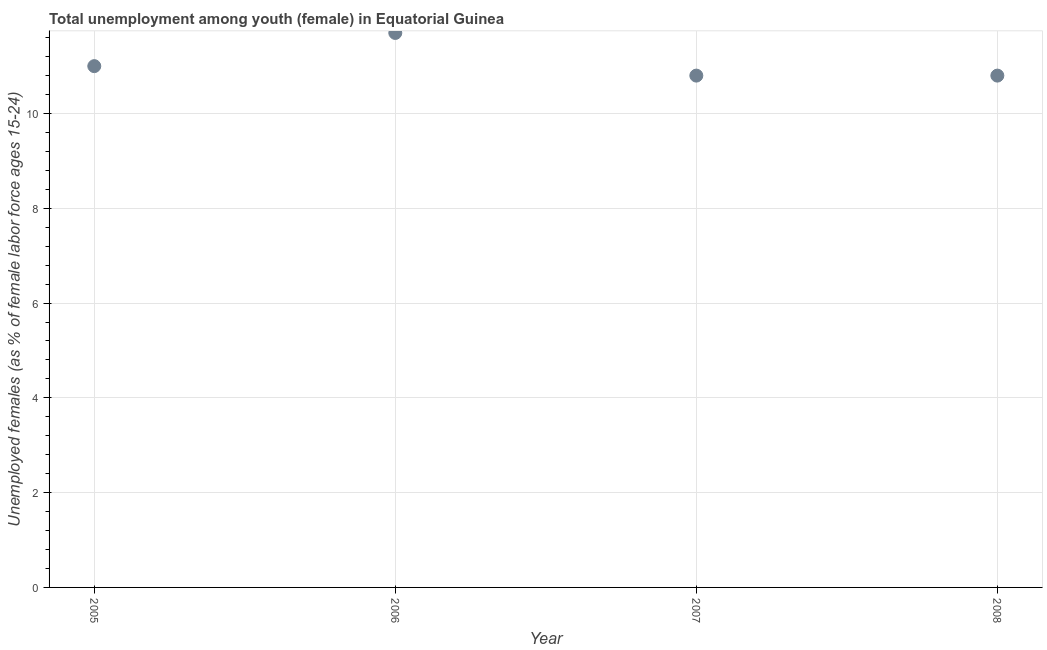What is the unemployed female youth population in 2007?
Keep it short and to the point. 10.8. Across all years, what is the maximum unemployed female youth population?
Your answer should be compact. 11.7. Across all years, what is the minimum unemployed female youth population?
Provide a short and direct response. 10.8. In which year was the unemployed female youth population minimum?
Make the answer very short. 2007. What is the sum of the unemployed female youth population?
Make the answer very short. 44.3. What is the average unemployed female youth population per year?
Provide a succinct answer. 11.08. What is the median unemployed female youth population?
Keep it short and to the point. 10.9. In how many years, is the unemployed female youth population greater than 10.8 %?
Provide a short and direct response. 4. Do a majority of the years between 2006 and 2008 (inclusive) have unemployed female youth population greater than 4.4 %?
Offer a very short reply. Yes. What is the ratio of the unemployed female youth population in 2006 to that in 2008?
Offer a very short reply. 1.08. What is the difference between the highest and the second highest unemployed female youth population?
Keep it short and to the point. 0.7. Is the sum of the unemployed female youth population in 2006 and 2008 greater than the maximum unemployed female youth population across all years?
Your response must be concise. Yes. What is the difference between the highest and the lowest unemployed female youth population?
Offer a very short reply. 0.9. In how many years, is the unemployed female youth population greater than the average unemployed female youth population taken over all years?
Keep it short and to the point. 1. How many dotlines are there?
Ensure brevity in your answer.  1. Does the graph contain any zero values?
Offer a very short reply. No. What is the title of the graph?
Keep it short and to the point. Total unemployment among youth (female) in Equatorial Guinea. What is the label or title of the Y-axis?
Make the answer very short. Unemployed females (as % of female labor force ages 15-24). What is the Unemployed females (as % of female labor force ages 15-24) in 2006?
Offer a very short reply. 11.7. What is the Unemployed females (as % of female labor force ages 15-24) in 2007?
Offer a very short reply. 10.8. What is the Unemployed females (as % of female labor force ages 15-24) in 2008?
Keep it short and to the point. 10.8. What is the difference between the Unemployed females (as % of female labor force ages 15-24) in 2005 and 2006?
Ensure brevity in your answer.  -0.7. What is the difference between the Unemployed females (as % of female labor force ages 15-24) in 2005 and 2007?
Your answer should be compact. 0.2. What is the difference between the Unemployed females (as % of female labor force ages 15-24) in 2005 and 2008?
Make the answer very short. 0.2. What is the difference between the Unemployed females (as % of female labor force ages 15-24) in 2006 and 2008?
Offer a terse response. 0.9. What is the ratio of the Unemployed females (as % of female labor force ages 15-24) in 2005 to that in 2008?
Ensure brevity in your answer.  1.02. What is the ratio of the Unemployed females (as % of female labor force ages 15-24) in 2006 to that in 2007?
Your answer should be very brief. 1.08. What is the ratio of the Unemployed females (as % of female labor force ages 15-24) in 2006 to that in 2008?
Offer a very short reply. 1.08. What is the ratio of the Unemployed females (as % of female labor force ages 15-24) in 2007 to that in 2008?
Provide a short and direct response. 1. 